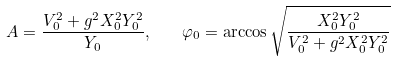<formula> <loc_0><loc_0><loc_500><loc_500>A = \frac { V _ { 0 } ^ { 2 } + g ^ { 2 } X _ { 0 } ^ { 2 } Y _ { 0 } ^ { 2 } } { Y _ { 0 } } , \quad \varphi _ { 0 } = \arccos \sqrt { \frac { X _ { 0 } ^ { 2 } Y _ { 0 } ^ { 2 } } { V _ { 0 } ^ { 2 } + g ^ { 2 } X _ { 0 } ^ { 2 } Y _ { 0 } ^ { 2 } } }</formula> 